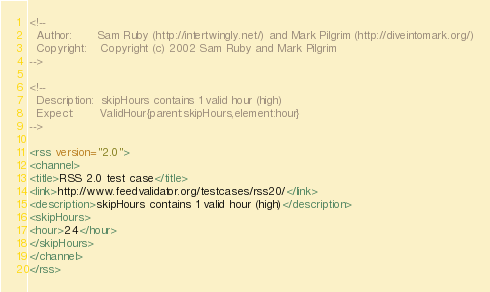<code> <loc_0><loc_0><loc_500><loc_500><_XML_><!--
  Author:       Sam Ruby (http://intertwingly.net/) and Mark Pilgrim (http://diveintomark.org/)
  Copyright:    Copyright (c) 2002 Sam Ruby and Mark Pilgrim
-->

<!--
  Description:  skipHours contains 1 valid hour (high)
  Expect:       ValidHour{parent:skipHours,element:hour}
-->

<rss version="2.0">
<channel>
<title>RSS 2.0 test case</title>
<link>http://www.feedvalidator.org/testcases/rss20/</link>
<description>skipHours contains 1 valid hour (high)</description>
<skipHours>
<hour>24</hour>
</skipHours>
</channel>
</rss>
</code> 